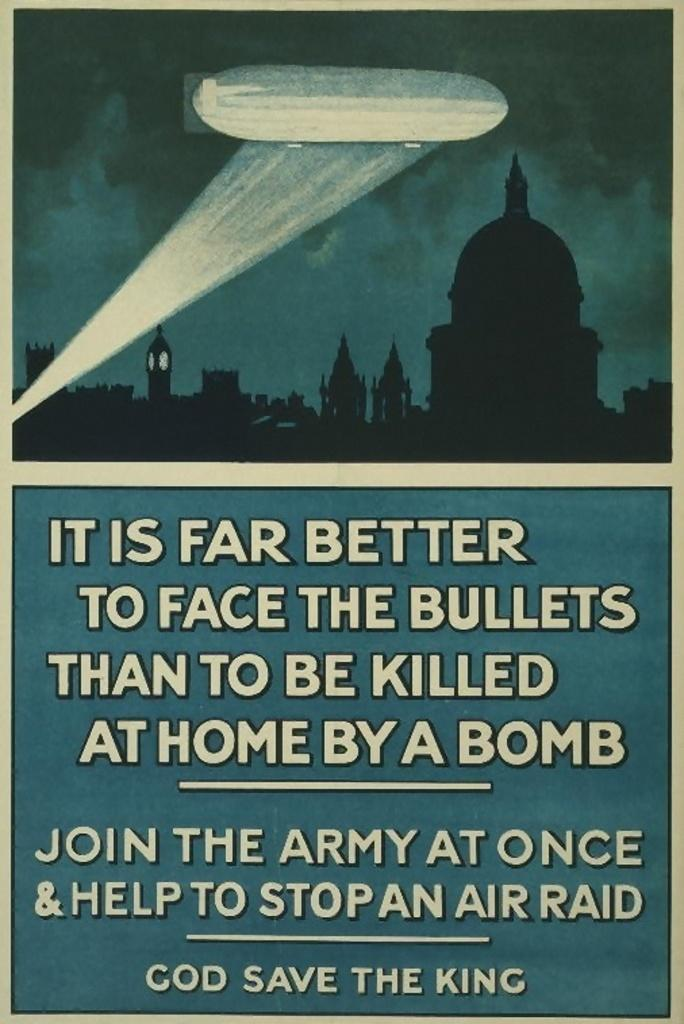<image>
Summarize the visual content of the image. Underneath a cartoon drawing of a city a night is an advertisement to join the army and help stop an air raid. 